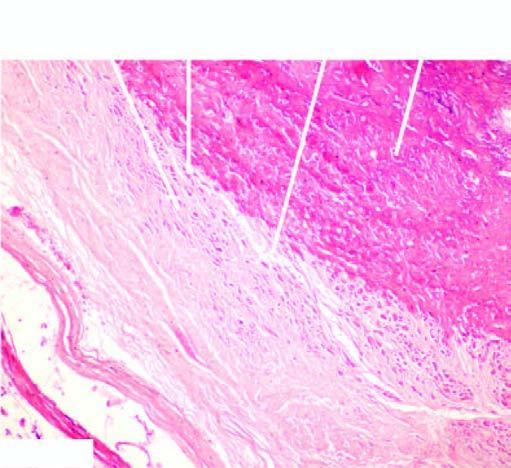do the whorls composed of the smooth muscle cells and fibroblasts show osseous metaplasia in the centre?
Answer the question using a single word or phrase. Yes 